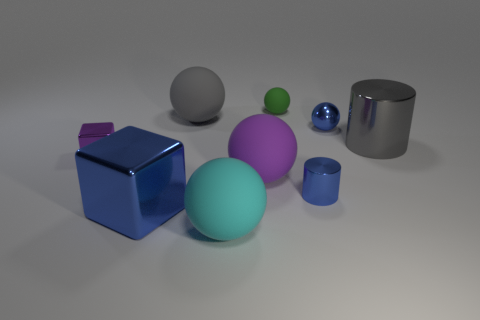Subtract 2 spheres. How many spheres are left? 3 Subtract all brown spheres. Subtract all green cylinders. How many spheres are left? 5 Add 1 small gray rubber blocks. How many objects exist? 10 Subtract all balls. How many objects are left? 4 Add 1 blue cylinders. How many blue cylinders are left? 2 Add 8 big green metallic things. How many big green metallic things exist? 8 Subtract 0 cyan cylinders. How many objects are left? 9 Subtract all big cyan cubes. Subtract all small objects. How many objects are left? 5 